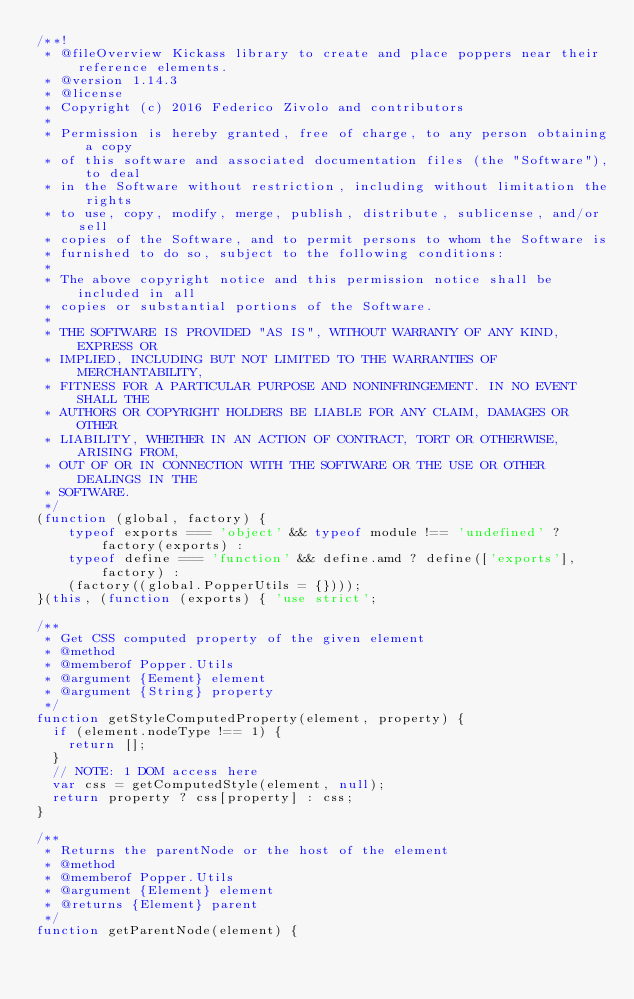<code> <loc_0><loc_0><loc_500><loc_500><_JavaScript_>/**!
 * @fileOverview Kickass library to create and place poppers near their reference elements.
 * @version 1.14.3
 * @license
 * Copyright (c) 2016 Federico Zivolo and contributors
 *
 * Permission is hereby granted, free of charge, to any person obtaining a copy
 * of this software and associated documentation files (the "Software"), to deal
 * in the Software without restriction, including without limitation the rights
 * to use, copy, modify, merge, publish, distribute, sublicense, and/or sell
 * copies of the Software, and to permit persons to whom the Software is
 * furnished to do so, subject to the following conditions:
 *
 * The above copyright notice and this permission notice shall be included in all
 * copies or substantial portions of the Software.
 *
 * THE SOFTWARE IS PROVIDED "AS IS", WITHOUT WARRANTY OF ANY KIND, EXPRESS OR
 * IMPLIED, INCLUDING BUT NOT LIMITED TO THE WARRANTIES OF MERCHANTABILITY,
 * FITNESS FOR A PARTICULAR PURPOSE AND NONINFRINGEMENT. IN NO EVENT SHALL THE
 * AUTHORS OR COPYRIGHT HOLDERS BE LIABLE FOR ANY CLAIM, DAMAGES OR OTHER
 * LIABILITY, WHETHER IN AN ACTION OF CONTRACT, TORT OR OTHERWISE, ARISING FROM,
 * OUT OF OR IN CONNECTION WITH THE SOFTWARE OR THE USE OR OTHER DEALINGS IN THE
 * SOFTWARE.
 */
(function (global, factory) {
	typeof exports === 'object' && typeof module !== 'undefined' ? factory(exports) :
	typeof define === 'function' && define.amd ? define(['exports'], factory) :
	(factory((global.PopperUtils = {})));
}(this, (function (exports) { 'use strict';

/**
 * Get CSS computed property of the given element
 * @method
 * @memberof Popper.Utils
 * @argument {Eement} element
 * @argument {String} property
 */
function getStyleComputedProperty(element, property) {
  if (element.nodeType !== 1) {
    return [];
  }
  // NOTE: 1 DOM access here
  var css = getComputedStyle(element, null);
  return property ? css[property] : css;
}

/**
 * Returns the parentNode or the host of the element
 * @method
 * @memberof Popper.Utils
 * @argument {Element} element
 * @returns {Element} parent
 */
function getParentNode(element) {</code> 